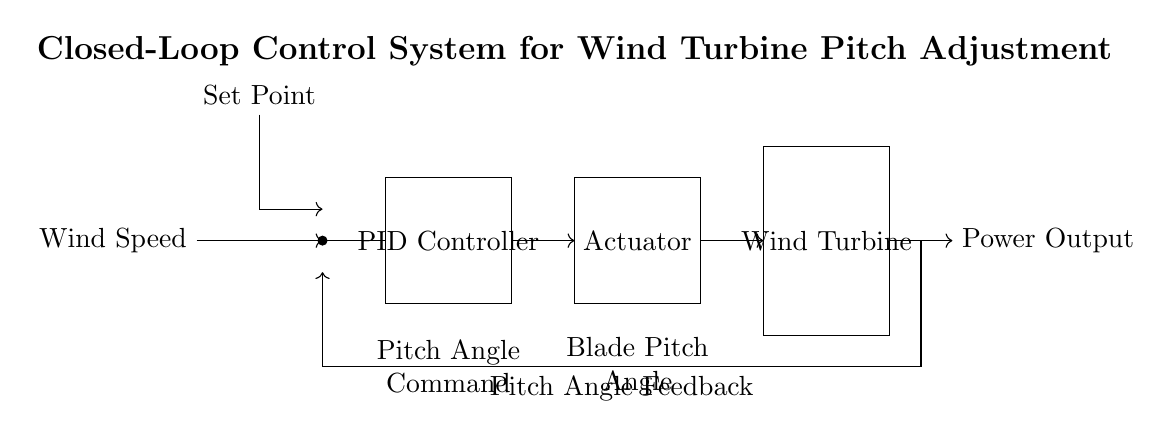What is the input variable in the control system? The input variable is the wind speed, which indicates the condition that the control system must respond to in order to adjust the pitch of the turbine blades.
Answer: Wind Speed What component receives the feedback signal? The PID Controller receives the feedback signal from the pitch angle, allowing it to compare the current state with the set point for adjustments.
Answer: PID Controller What is the purpose of the actuator in this system? The actuator is responsible for applying the control command to adjust the pitch angle of the turbine blades according to the output from the PID Controller.
Answer: Adjust pitch angle Where does the set point originate in the diagram? The set point originates from the input labeled "Set Point" that defines the desired pitch angle for the wind turbine.
Answer: Set Point Which component directly converts wind energy into electrical power? The Wind Turbine component directly converts wind energy into electrical power, utilizing the adjusted pitch angles for optimal performance.
Answer: Wind Turbine How does feedback influence the control system? Feedback provides information about the pitch angle, allowing the PID Controller to make necessary adjustments to minimize error between the set point and actual angle, maintaining efficient operation.
Answer: Determines adjustment What type of control algorithm is used in the system? The system uses a PID (Proportional-Integral-Derivative) control algorithm, which combines proportional control with integral and derivative actions to improve responsiveness and stability.
Answer: PID 